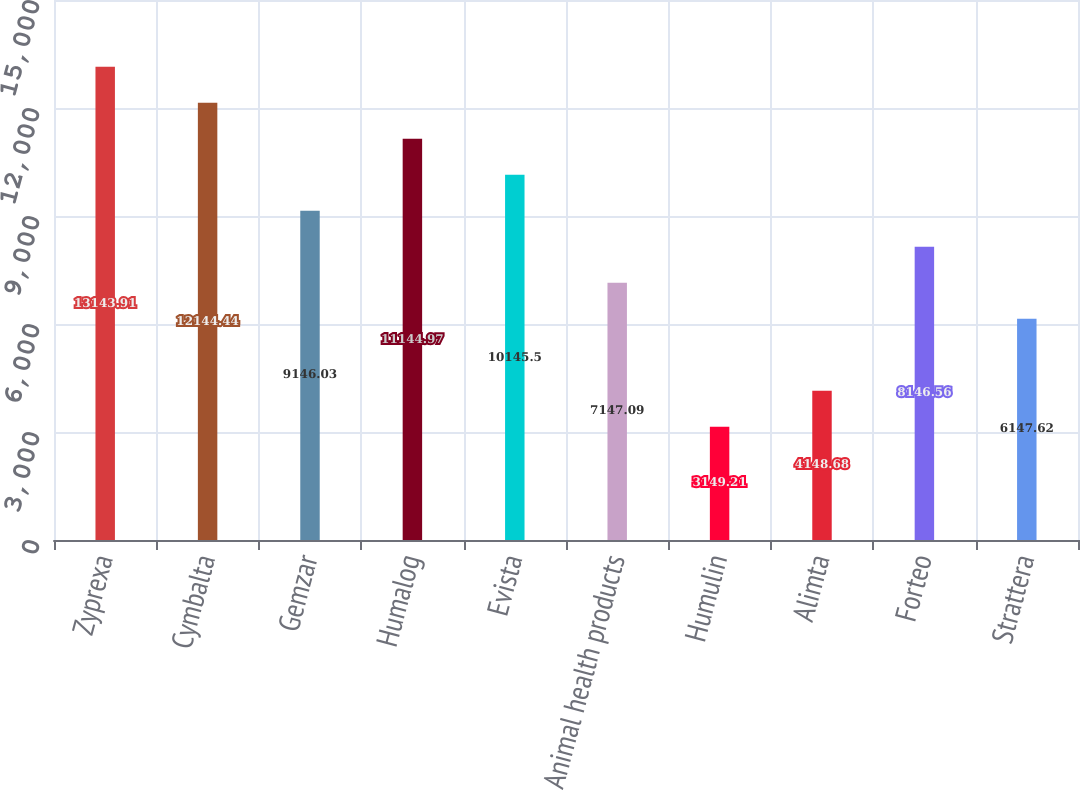Convert chart. <chart><loc_0><loc_0><loc_500><loc_500><bar_chart><fcel>Zyprexa<fcel>Cymbalta<fcel>Gemzar<fcel>Humalog<fcel>Evista<fcel>Animal health products<fcel>Humulin<fcel>Alimta<fcel>Forteo<fcel>Strattera<nl><fcel>13143.9<fcel>12144.4<fcel>9146.03<fcel>11145<fcel>10145.5<fcel>7147.09<fcel>3149.21<fcel>4148.68<fcel>8146.56<fcel>6147.62<nl></chart> 